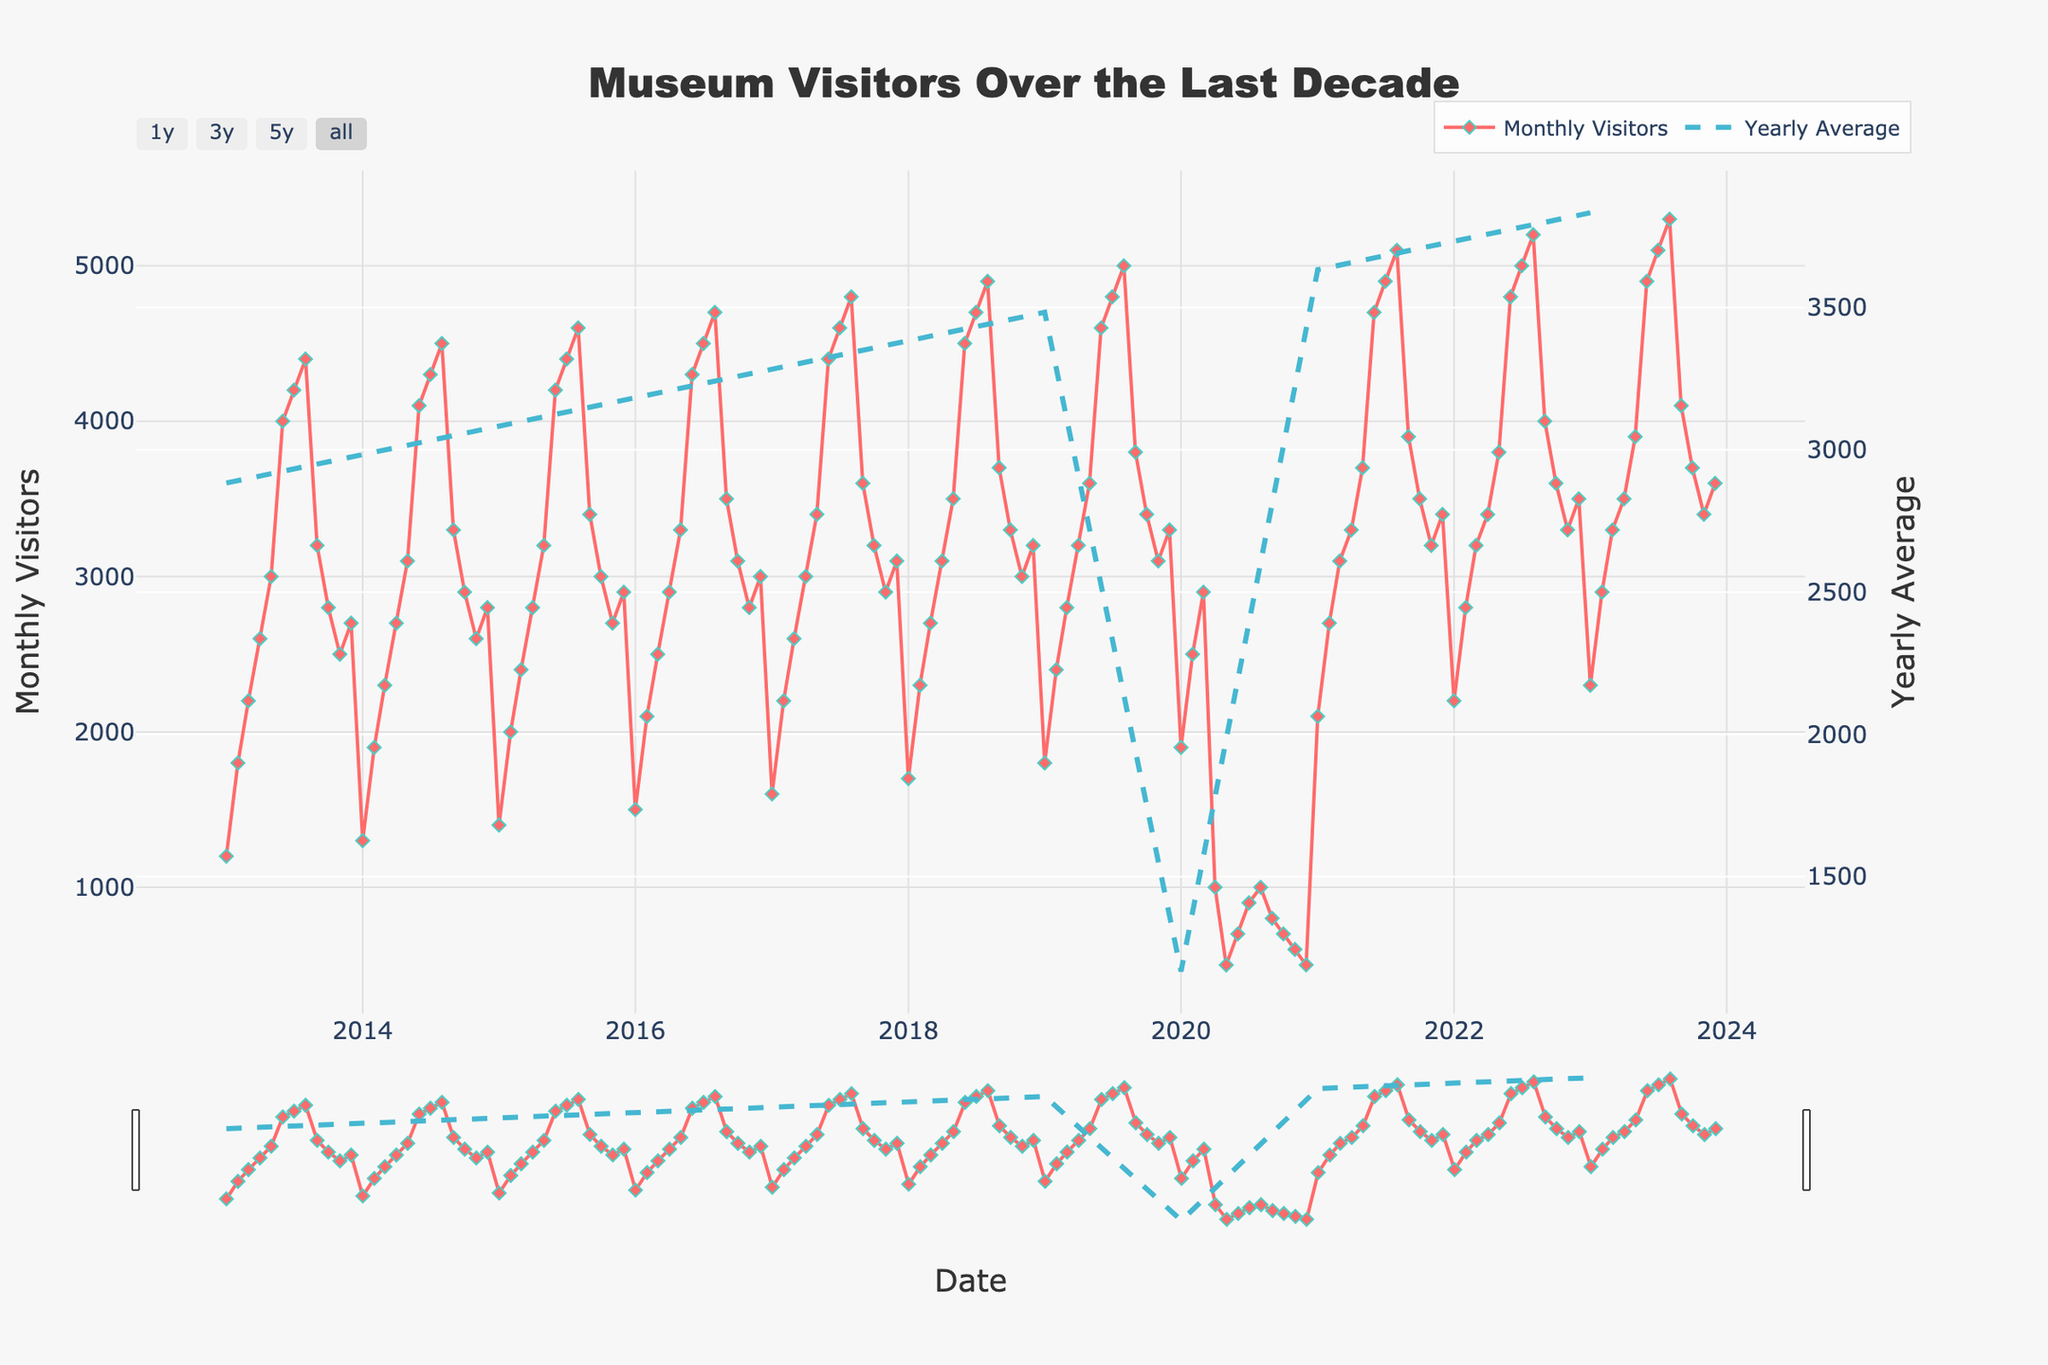What is the title of the plot? The title of the plot is displayed prominently at the top of the figure. It reads "Museum Visitors Over the Last Decade."
Answer: Museum Visitors Over the Last Decade What do the red diamonds represent? The red diamonds, connected by lines, represent the monthly number of visitors to the museum. This is evident from both the color and the legend labeling them as "Monthly Visitors."
Answer: Monthly Visitors Which year shows the lowest number of visitors in a single month? By observing the monthly visitor values plotted for each year, the lowest number of visitors occurs in the year 2020, during the months of April, May, and December, where it plunges significantly.
Answer: 2020 Around which month does the visitor count peak each year? By tracking the highest points in each annual cycle, it's clear that the count tends to peak around July and August every year.
Answer: July and August What trend is visible during the summer months over the decade? The trend shows a consistent increase in visitor numbers during the summer months of June, July, and August each year.
Answer: Increase in summer How did the visitor numbers change in 2020, and why could this be? In 2020, the number of visitors dropped drastically, especially during the middle of the year. This could be attributed to the impacts of the COVID-19 pandemic, which caused closures and reduced travel.
Answer: Drastically dropped, likely due to COVID-19 What is the average number of visitors in 2017? By examining the line representing the yearly average and matching it to 2017 on the x-axis, the average number of visitors is indicated by the yearly average line.
Answer: Approximately 3167 Do June and December months show consistent patterns each year? Upon examining both June and December for each year, June consistently shows high visitor counts, while December shows fluctuating but generally lower counts.
Answer: Yes, June is high, December fluctuates low Which month in 2023 had the highest visitor count? By locating the highest point in 2023 on the plot, it's evident that August had the highest count with approximately 5300 visitors.
Answer: August Compare the visitor trends between 2021 and 2022. What can you infer? Comparing the trends for these two years, 2022 shows a higher baseline for monthly visitor numbers, suggesting recovery and growth from the lower figures seen previously in 2021.
Answer: 2022 shows higher visitor numbers than 2021 